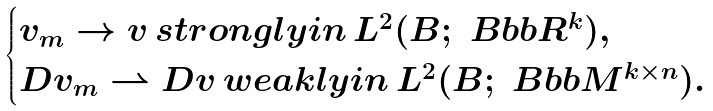<formula> <loc_0><loc_0><loc_500><loc_500>\begin{cases} v _ { m } \to v \, s t r o n g l y i n \, L ^ { 2 } ( B ; \ B b b R ^ { k } ) , \\ D v _ { m } \rightharpoonup D v \, w e a k l y i n \, L ^ { 2 } ( B ; \ B b b M ^ { k \times n } ) . \end{cases}</formula> 